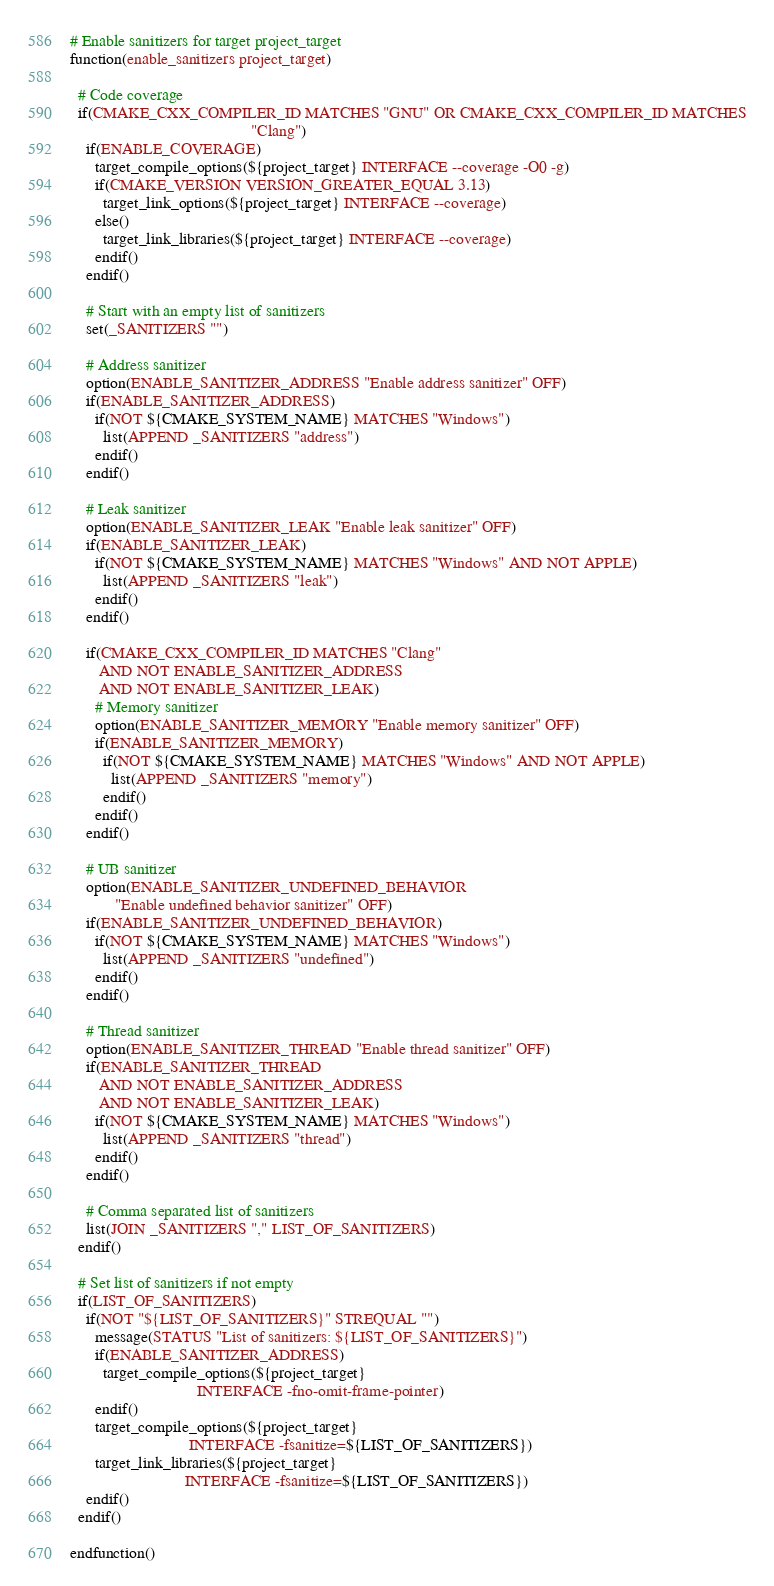Convert code to text. <code><loc_0><loc_0><loc_500><loc_500><_CMake_># Enable sanitizers for target project_target
function(enable_sanitizers project_target)

  # Code coverage
  if(CMAKE_CXX_COMPILER_ID MATCHES "GNU" OR CMAKE_CXX_COMPILER_ID MATCHES
                                            "Clang")
    if(ENABLE_COVERAGE)
      target_compile_options(${project_target} INTERFACE --coverage -O0 -g)
      if(CMAKE_VERSION VERSION_GREATER_EQUAL 3.13)
        target_link_options(${project_target} INTERFACE --coverage)
      else()
        target_link_libraries(${project_target} INTERFACE --coverage)
      endif()
    endif()

    # Start with an empty list of sanitizers
    set(_SANITIZERS "")

    # Address sanitizer
    option(ENABLE_SANITIZER_ADDRESS "Enable address sanitizer" OFF)
    if(ENABLE_SANITIZER_ADDRESS)
      if(NOT ${CMAKE_SYSTEM_NAME} MATCHES "Windows")
        list(APPEND _SANITIZERS "address")
      endif()
    endif()

    # Leak sanitizer
    option(ENABLE_SANITIZER_LEAK "Enable leak sanitizer" OFF)
    if(ENABLE_SANITIZER_LEAK)
      if(NOT ${CMAKE_SYSTEM_NAME} MATCHES "Windows" AND NOT APPLE)
        list(APPEND _SANITIZERS "leak")
      endif()
    endif()

    if(CMAKE_CXX_COMPILER_ID MATCHES "Clang"
       AND NOT ENABLE_SANITIZER_ADDRESS
       AND NOT ENABLE_SANITIZER_LEAK)
      # Memory sanitizer
      option(ENABLE_SANITIZER_MEMORY "Enable memory sanitizer" OFF)
      if(ENABLE_SANITIZER_MEMORY)
        if(NOT ${CMAKE_SYSTEM_NAME} MATCHES "Windows" AND NOT APPLE)
          list(APPEND _SANITIZERS "memory")
        endif()
      endif()
    endif()

    # UB sanitizer
    option(ENABLE_SANITIZER_UNDEFINED_BEHAVIOR
           "Enable undefined behavior sanitizer" OFF)
    if(ENABLE_SANITIZER_UNDEFINED_BEHAVIOR)
      if(NOT ${CMAKE_SYSTEM_NAME} MATCHES "Windows")
        list(APPEND _SANITIZERS "undefined")
      endif()
    endif()

    # Thread sanitizer
    option(ENABLE_SANITIZER_THREAD "Enable thread sanitizer" OFF)
    if(ENABLE_SANITIZER_THREAD
       AND NOT ENABLE_SANITIZER_ADDRESS
       AND NOT ENABLE_SANITIZER_LEAK)
      if(NOT ${CMAKE_SYSTEM_NAME} MATCHES "Windows")
        list(APPEND _SANITIZERS "thread")
      endif()
    endif()

    # Comma separated list of sanitizers
    list(JOIN _SANITIZERS "," LIST_OF_SANITIZERS)
  endif()

  # Set list of sanitizers if not empty
  if(LIST_OF_SANITIZERS)
    if(NOT "${LIST_OF_SANITIZERS}" STREQUAL "")
      message(STATUS "List of sanitizers: ${LIST_OF_SANITIZERS}")
      if(ENABLE_SANITIZER_ADDRESS)
        target_compile_options(${project_target}
                               INTERFACE -fno-omit-frame-pointer)
      endif()
      target_compile_options(${project_target}
                             INTERFACE -fsanitize=${LIST_OF_SANITIZERS})
      target_link_libraries(${project_target}
                            INTERFACE -fsanitize=${LIST_OF_SANITIZERS})
    endif()
  endif()

endfunction()
</code> 